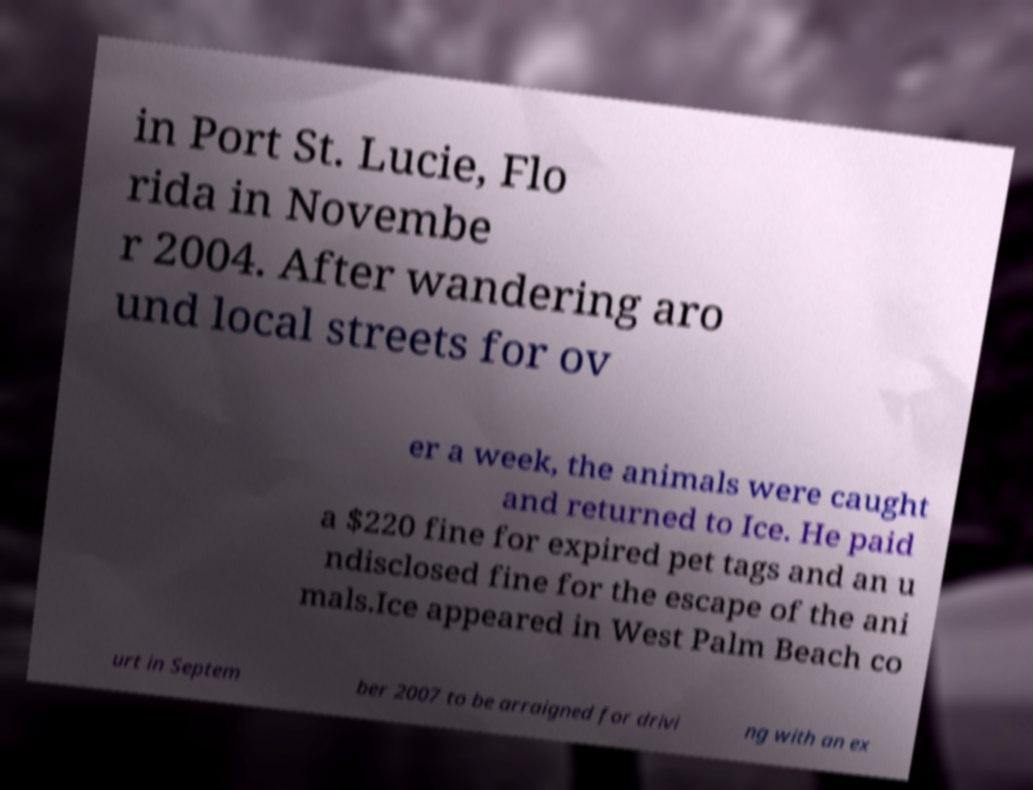Could you extract and type out the text from this image? in Port St. Lucie, Flo rida in Novembe r 2004. After wandering aro und local streets for ov er a week, the animals were caught and returned to Ice. He paid a $220 fine for expired pet tags and an u ndisclosed fine for the escape of the ani mals.Ice appeared in West Palm Beach co urt in Septem ber 2007 to be arraigned for drivi ng with an ex 